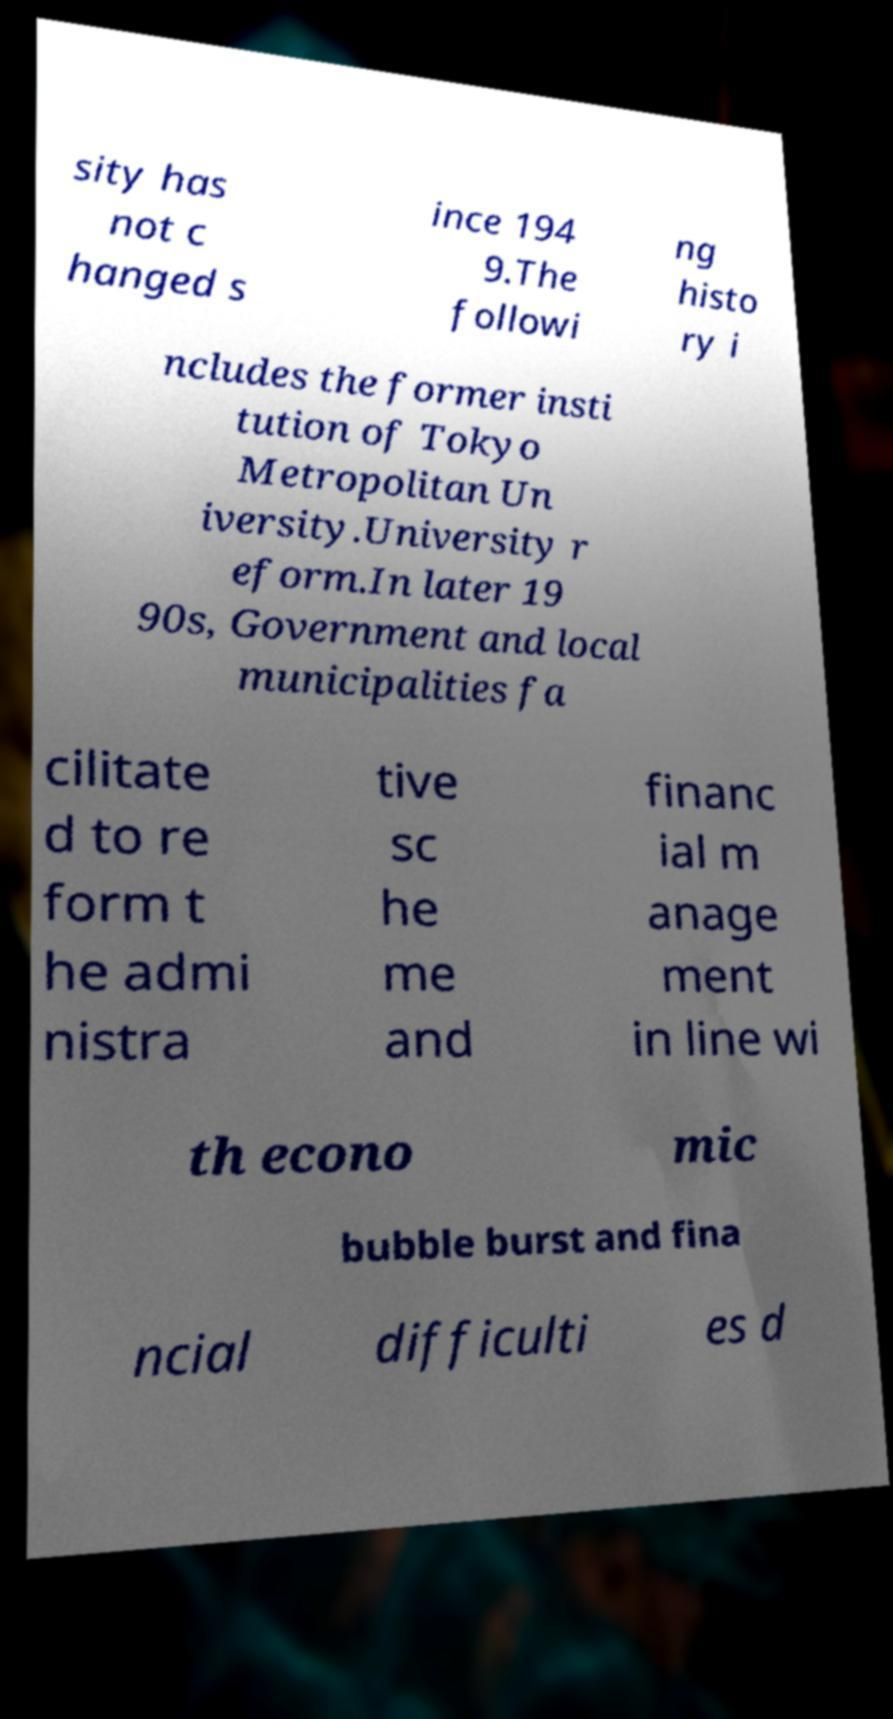Please identify and transcribe the text found in this image. sity has not c hanged s ince 194 9.The followi ng histo ry i ncludes the former insti tution of Tokyo Metropolitan Un iversity.University r eform.In later 19 90s, Government and local municipalities fa cilitate d to re form t he admi nistra tive sc he me and financ ial m anage ment in line wi th econo mic bubble burst and fina ncial difficulti es d 